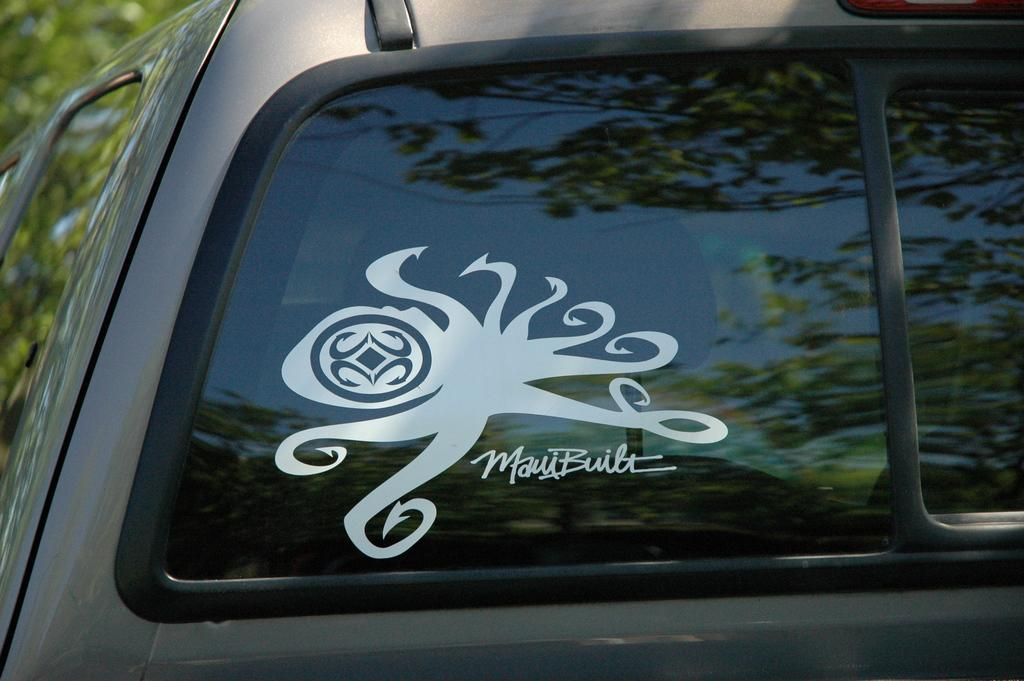What type of vehicle is in the image? There is a grey color vehicle in the image. What else can be seen in the image besides the vehicle? There is a glass visible in the image. Are there any additional details about the vehicle? Yes, there is a white color sticker attached to the vehicle. What can be seen in the background of the image? There are trees visible in the background of the image. How many ladybugs are crawling on the vehicle in the image? There are no ladybugs visible in the image; the focus is on the grey color vehicle, glass, and white color sticker. 